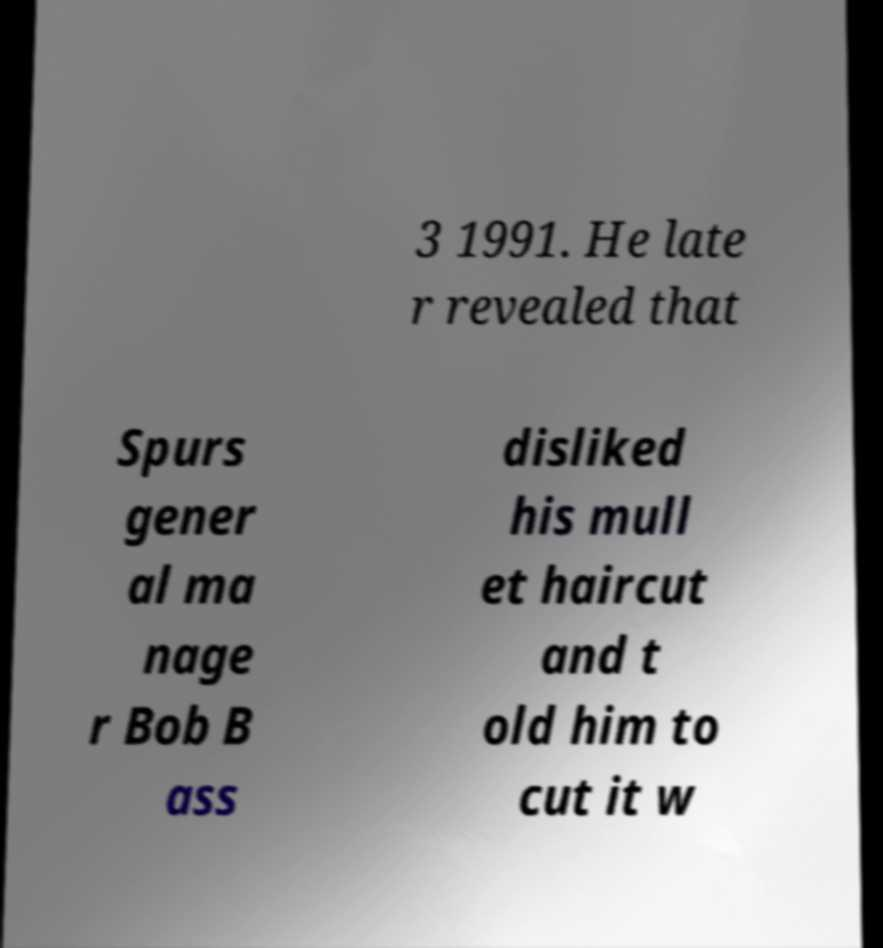Could you extract and type out the text from this image? 3 1991. He late r revealed that Spurs gener al ma nage r Bob B ass disliked his mull et haircut and t old him to cut it w 